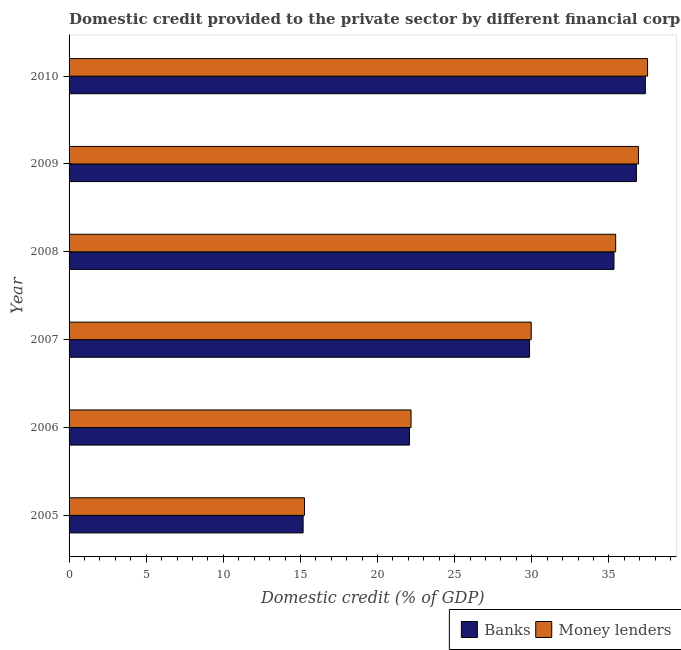How many groups of bars are there?
Your answer should be very brief. 6. Are the number of bars on each tick of the Y-axis equal?
Your answer should be very brief. Yes. How many bars are there on the 5th tick from the bottom?
Ensure brevity in your answer.  2. In how many cases, is the number of bars for a given year not equal to the number of legend labels?
Provide a succinct answer. 0. What is the domestic credit provided by banks in 2008?
Your answer should be very brief. 35.33. Across all years, what is the maximum domestic credit provided by money lenders?
Offer a very short reply. 37.51. Across all years, what is the minimum domestic credit provided by money lenders?
Your answer should be compact. 15.26. In which year was the domestic credit provided by banks minimum?
Your answer should be compact. 2005. What is the total domestic credit provided by money lenders in the graph?
Your answer should be very brief. 177.27. What is the difference between the domestic credit provided by banks in 2008 and that in 2009?
Offer a terse response. -1.45. What is the difference between the domestic credit provided by money lenders in 2009 and the domestic credit provided by banks in 2010?
Provide a succinct answer. -0.45. What is the average domestic credit provided by money lenders per year?
Make the answer very short. 29.55. In the year 2009, what is the difference between the domestic credit provided by banks and domestic credit provided by money lenders?
Make the answer very short. -0.13. What is the ratio of the domestic credit provided by money lenders in 2007 to that in 2009?
Keep it short and to the point. 0.81. What is the difference between the highest and the second highest domestic credit provided by banks?
Ensure brevity in your answer.  0.58. What is the difference between the highest and the lowest domestic credit provided by money lenders?
Your answer should be very brief. 22.24. In how many years, is the domestic credit provided by money lenders greater than the average domestic credit provided by money lenders taken over all years?
Make the answer very short. 4. What does the 2nd bar from the top in 2005 represents?
Give a very brief answer. Banks. What does the 2nd bar from the bottom in 2005 represents?
Make the answer very short. Money lenders. How many bars are there?
Make the answer very short. 12. Are all the bars in the graph horizontal?
Your response must be concise. Yes. What is the difference between two consecutive major ticks on the X-axis?
Keep it short and to the point. 5. Does the graph contain any zero values?
Offer a terse response. No. Does the graph contain grids?
Your answer should be very brief. No. How many legend labels are there?
Provide a short and direct response. 2. How are the legend labels stacked?
Give a very brief answer. Horizontal. What is the title of the graph?
Offer a very short reply. Domestic credit provided to the private sector by different financial corporations in Albania. What is the label or title of the X-axis?
Offer a terse response. Domestic credit (% of GDP). What is the Domestic credit (% of GDP) in Banks in 2005?
Ensure brevity in your answer.  15.18. What is the Domestic credit (% of GDP) of Money lenders in 2005?
Provide a succinct answer. 15.26. What is the Domestic credit (% of GDP) in Banks in 2006?
Ensure brevity in your answer.  22.07. What is the Domestic credit (% of GDP) of Money lenders in 2006?
Your response must be concise. 22.17. What is the Domestic credit (% of GDP) of Banks in 2007?
Keep it short and to the point. 29.86. What is the Domestic credit (% of GDP) of Money lenders in 2007?
Give a very brief answer. 29.96. What is the Domestic credit (% of GDP) in Banks in 2008?
Ensure brevity in your answer.  35.33. What is the Domestic credit (% of GDP) of Money lenders in 2008?
Your response must be concise. 35.44. What is the Domestic credit (% of GDP) in Banks in 2009?
Offer a terse response. 36.78. What is the Domestic credit (% of GDP) of Money lenders in 2009?
Give a very brief answer. 36.92. What is the Domestic credit (% of GDP) in Banks in 2010?
Make the answer very short. 37.37. What is the Domestic credit (% of GDP) in Money lenders in 2010?
Your response must be concise. 37.51. Across all years, what is the maximum Domestic credit (% of GDP) of Banks?
Give a very brief answer. 37.37. Across all years, what is the maximum Domestic credit (% of GDP) of Money lenders?
Keep it short and to the point. 37.51. Across all years, what is the minimum Domestic credit (% of GDP) of Banks?
Offer a terse response. 15.18. Across all years, what is the minimum Domestic credit (% of GDP) in Money lenders?
Make the answer very short. 15.26. What is the total Domestic credit (% of GDP) in Banks in the graph?
Offer a terse response. 176.59. What is the total Domestic credit (% of GDP) of Money lenders in the graph?
Make the answer very short. 177.27. What is the difference between the Domestic credit (% of GDP) of Banks in 2005 and that in 2006?
Offer a very short reply. -6.9. What is the difference between the Domestic credit (% of GDP) of Money lenders in 2005 and that in 2006?
Your answer should be compact. -6.91. What is the difference between the Domestic credit (% of GDP) in Banks in 2005 and that in 2007?
Provide a succinct answer. -14.68. What is the difference between the Domestic credit (% of GDP) in Money lenders in 2005 and that in 2007?
Keep it short and to the point. -14.7. What is the difference between the Domestic credit (% of GDP) in Banks in 2005 and that in 2008?
Ensure brevity in your answer.  -20.16. What is the difference between the Domestic credit (% of GDP) of Money lenders in 2005 and that in 2008?
Your response must be concise. -20.18. What is the difference between the Domestic credit (% of GDP) in Banks in 2005 and that in 2009?
Your response must be concise. -21.61. What is the difference between the Domestic credit (% of GDP) in Money lenders in 2005 and that in 2009?
Make the answer very short. -21.65. What is the difference between the Domestic credit (% of GDP) of Banks in 2005 and that in 2010?
Provide a succinct answer. -22.19. What is the difference between the Domestic credit (% of GDP) in Money lenders in 2005 and that in 2010?
Your response must be concise. -22.24. What is the difference between the Domestic credit (% of GDP) in Banks in 2006 and that in 2007?
Provide a succinct answer. -7.78. What is the difference between the Domestic credit (% of GDP) in Money lenders in 2006 and that in 2007?
Provide a succinct answer. -7.79. What is the difference between the Domestic credit (% of GDP) in Banks in 2006 and that in 2008?
Your answer should be very brief. -13.26. What is the difference between the Domestic credit (% of GDP) of Money lenders in 2006 and that in 2008?
Make the answer very short. -13.27. What is the difference between the Domestic credit (% of GDP) of Banks in 2006 and that in 2009?
Provide a short and direct response. -14.71. What is the difference between the Domestic credit (% of GDP) in Money lenders in 2006 and that in 2009?
Keep it short and to the point. -14.74. What is the difference between the Domestic credit (% of GDP) of Banks in 2006 and that in 2010?
Your response must be concise. -15.29. What is the difference between the Domestic credit (% of GDP) in Money lenders in 2006 and that in 2010?
Your answer should be very brief. -15.34. What is the difference between the Domestic credit (% of GDP) in Banks in 2007 and that in 2008?
Provide a short and direct response. -5.48. What is the difference between the Domestic credit (% of GDP) of Money lenders in 2007 and that in 2008?
Make the answer very short. -5.48. What is the difference between the Domestic credit (% of GDP) in Banks in 2007 and that in 2009?
Give a very brief answer. -6.93. What is the difference between the Domestic credit (% of GDP) of Money lenders in 2007 and that in 2009?
Ensure brevity in your answer.  -6.95. What is the difference between the Domestic credit (% of GDP) of Banks in 2007 and that in 2010?
Your answer should be very brief. -7.51. What is the difference between the Domestic credit (% of GDP) in Money lenders in 2007 and that in 2010?
Ensure brevity in your answer.  -7.54. What is the difference between the Domestic credit (% of GDP) of Banks in 2008 and that in 2009?
Ensure brevity in your answer.  -1.45. What is the difference between the Domestic credit (% of GDP) of Money lenders in 2008 and that in 2009?
Your response must be concise. -1.48. What is the difference between the Domestic credit (% of GDP) of Banks in 2008 and that in 2010?
Ensure brevity in your answer.  -2.03. What is the difference between the Domestic credit (% of GDP) of Money lenders in 2008 and that in 2010?
Make the answer very short. -2.07. What is the difference between the Domestic credit (% of GDP) of Banks in 2009 and that in 2010?
Make the answer very short. -0.58. What is the difference between the Domestic credit (% of GDP) in Money lenders in 2009 and that in 2010?
Provide a succinct answer. -0.59. What is the difference between the Domestic credit (% of GDP) in Banks in 2005 and the Domestic credit (% of GDP) in Money lenders in 2006?
Your answer should be very brief. -7. What is the difference between the Domestic credit (% of GDP) in Banks in 2005 and the Domestic credit (% of GDP) in Money lenders in 2007?
Give a very brief answer. -14.79. What is the difference between the Domestic credit (% of GDP) of Banks in 2005 and the Domestic credit (% of GDP) of Money lenders in 2008?
Provide a succinct answer. -20.26. What is the difference between the Domestic credit (% of GDP) in Banks in 2005 and the Domestic credit (% of GDP) in Money lenders in 2009?
Offer a very short reply. -21.74. What is the difference between the Domestic credit (% of GDP) of Banks in 2005 and the Domestic credit (% of GDP) of Money lenders in 2010?
Ensure brevity in your answer.  -22.33. What is the difference between the Domestic credit (% of GDP) in Banks in 2006 and the Domestic credit (% of GDP) in Money lenders in 2007?
Give a very brief answer. -7.89. What is the difference between the Domestic credit (% of GDP) in Banks in 2006 and the Domestic credit (% of GDP) in Money lenders in 2008?
Provide a succinct answer. -13.37. What is the difference between the Domestic credit (% of GDP) of Banks in 2006 and the Domestic credit (% of GDP) of Money lenders in 2009?
Your answer should be compact. -14.84. What is the difference between the Domestic credit (% of GDP) of Banks in 2006 and the Domestic credit (% of GDP) of Money lenders in 2010?
Ensure brevity in your answer.  -15.43. What is the difference between the Domestic credit (% of GDP) in Banks in 2007 and the Domestic credit (% of GDP) in Money lenders in 2008?
Your answer should be very brief. -5.58. What is the difference between the Domestic credit (% of GDP) in Banks in 2007 and the Domestic credit (% of GDP) in Money lenders in 2009?
Provide a short and direct response. -7.06. What is the difference between the Domestic credit (% of GDP) in Banks in 2007 and the Domestic credit (% of GDP) in Money lenders in 2010?
Keep it short and to the point. -7.65. What is the difference between the Domestic credit (% of GDP) of Banks in 2008 and the Domestic credit (% of GDP) of Money lenders in 2009?
Your answer should be very brief. -1.59. What is the difference between the Domestic credit (% of GDP) of Banks in 2008 and the Domestic credit (% of GDP) of Money lenders in 2010?
Offer a very short reply. -2.18. What is the difference between the Domestic credit (% of GDP) of Banks in 2009 and the Domestic credit (% of GDP) of Money lenders in 2010?
Ensure brevity in your answer.  -0.72. What is the average Domestic credit (% of GDP) of Banks per year?
Provide a succinct answer. 29.43. What is the average Domestic credit (% of GDP) of Money lenders per year?
Ensure brevity in your answer.  29.54. In the year 2005, what is the difference between the Domestic credit (% of GDP) in Banks and Domestic credit (% of GDP) in Money lenders?
Provide a short and direct response. -0.09. In the year 2006, what is the difference between the Domestic credit (% of GDP) of Banks and Domestic credit (% of GDP) of Money lenders?
Offer a very short reply. -0.1. In the year 2007, what is the difference between the Domestic credit (% of GDP) in Banks and Domestic credit (% of GDP) in Money lenders?
Your answer should be compact. -0.11. In the year 2008, what is the difference between the Domestic credit (% of GDP) of Banks and Domestic credit (% of GDP) of Money lenders?
Offer a very short reply. -0.11. In the year 2009, what is the difference between the Domestic credit (% of GDP) of Banks and Domestic credit (% of GDP) of Money lenders?
Offer a terse response. -0.13. In the year 2010, what is the difference between the Domestic credit (% of GDP) in Banks and Domestic credit (% of GDP) in Money lenders?
Your answer should be compact. -0.14. What is the ratio of the Domestic credit (% of GDP) in Banks in 2005 to that in 2006?
Your response must be concise. 0.69. What is the ratio of the Domestic credit (% of GDP) of Money lenders in 2005 to that in 2006?
Keep it short and to the point. 0.69. What is the ratio of the Domestic credit (% of GDP) in Banks in 2005 to that in 2007?
Your answer should be compact. 0.51. What is the ratio of the Domestic credit (% of GDP) of Money lenders in 2005 to that in 2007?
Provide a short and direct response. 0.51. What is the ratio of the Domestic credit (% of GDP) in Banks in 2005 to that in 2008?
Keep it short and to the point. 0.43. What is the ratio of the Domestic credit (% of GDP) in Money lenders in 2005 to that in 2008?
Keep it short and to the point. 0.43. What is the ratio of the Domestic credit (% of GDP) of Banks in 2005 to that in 2009?
Ensure brevity in your answer.  0.41. What is the ratio of the Domestic credit (% of GDP) in Money lenders in 2005 to that in 2009?
Your response must be concise. 0.41. What is the ratio of the Domestic credit (% of GDP) in Banks in 2005 to that in 2010?
Provide a succinct answer. 0.41. What is the ratio of the Domestic credit (% of GDP) in Money lenders in 2005 to that in 2010?
Offer a very short reply. 0.41. What is the ratio of the Domestic credit (% of GDP) of Banks in 2006 to that in 2007?
Make the answer very short. 0.74. What is the ratio of the Domestic credit (% of GDP) of Money lenders in 2006 to that in 2007?
Offer a terse response. 0.74. What is the ratio of the Domestic credit (% of GDP) in Banks in 2006 to that in 2008?
Give a very brief answer. 0.62. What is the ratio of the Domestic credit (% of GDP) of Money lenders in 2006 to that in 2008?
Your answer should be compact. 0.63. What is the ratio of the Domestic credit (% of GDP) of Banks in 2006 to that in 2009?
Your response must be concise. 0.6. What is the ratio of the Domestic credit (% of GDP) of Money lenders in 2006 to that in 2009?
Offer a terse response. 0.6. What is the ratio of the Domestic credit (% of GDP) in Banks in 2006 to that in 2010?
Ensure brevity in your answer.  0.59. What is the ratio of the Domestic credit (% of GDP) in Money lenders in 2006 to that in 2010?
Provide a short and direct response. 0.59. What is the ratio of the Domestic credit (% of GDP) in Banks in 2007 to that in 2008?
Your answer should be very brief. 0.84. What is the ratio of the Domestic credit (% of GDP) in Money lenders in 2007 to that in 2008?
Offer a terse response. 0.85. What is the ratio of the Domestic credit (% of GDP) in Banks in 2007 to that in 2009?
Your answer should be compact. 0.81. What is the ratio of the Domestic credit (% of GDP) of Money lenders in 2007 to that in 2009?
Make the answer very short. 0.81. What is the ratio of the Domestic credit (% of GDP) of Banks in 2007 to that in 2010?
Provide a short and direct response. 0.8. What is the ratio of the Domestic credit (% of GDP) of Money lenders in 2007 to that in 2010?
Provide a succinct answer. 0.8. What is the ratio of the Domestic credit (% of GDP) in Banks in 2008 to that in 2009?
Give a very brief answer. 0.96. What is the ratio of the Domestic credit (% of GDP) of Banks in 2008 to that in 2010?
Give a very brief answer. 0.95. What is the ratio of the Domestic credit (% of GDP) in Money lenders in 2008 to that in 2010?
Your answer should be compact. 0.94. What is the ratio of the Domestic credit (% of GDP) of Banks in 2009 to that in 2010?
Ensure brevity in your answer.  0.98. What is the ratio of the Domestic credit (% of GDP) in Money lenders in 2009 to that in 2010?
Provide a succinct answer. 0.98. What is the difference between the highest and the second highest Domestic credit (% of GDP) of Banks?
Your response must be concise. 0.58. What is the difference between the highest and the second highest Domestic credit (% of GDP) of Money lenders?
Your answer should be very brief. 0.59. What is the difference between the highest and the lowest Domestic credit (% of GDP) of Banks?
Make the answer very short. 22.19. What is the difference between the highest and the lowest Domestic credit (% of GDP) of Money lenders?
Your answer should be compact. 22.24. 